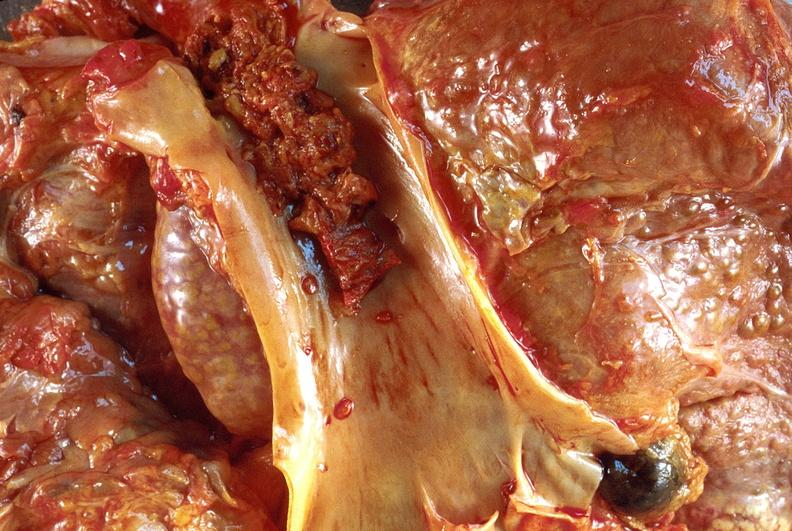what does this image show?
Answer the question using a single word or phrase. Hepatocellular carcinoma 